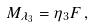<formula> <loc_0><loc_0><loc_500><loc_500>M _ { \lambda _ { 3 } } = \eta _ { 3 } F \, ,</formula> 